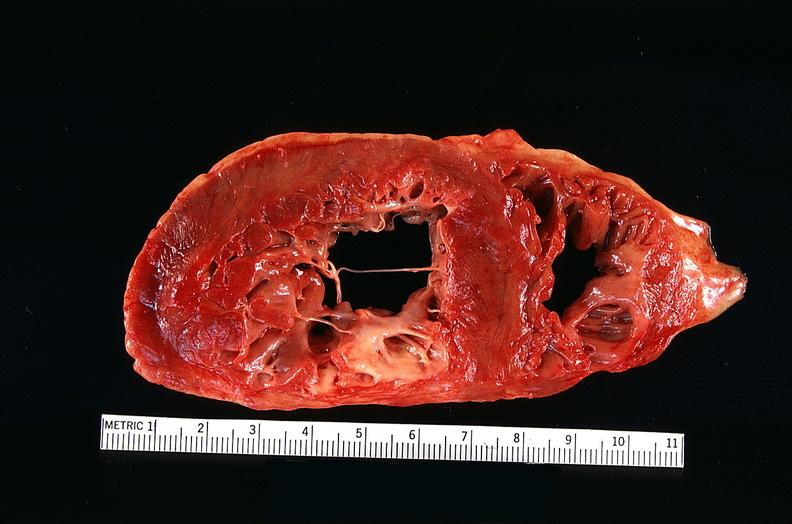what does this image show?
Answer the question using a single word or phrase. Congestive heart failure 